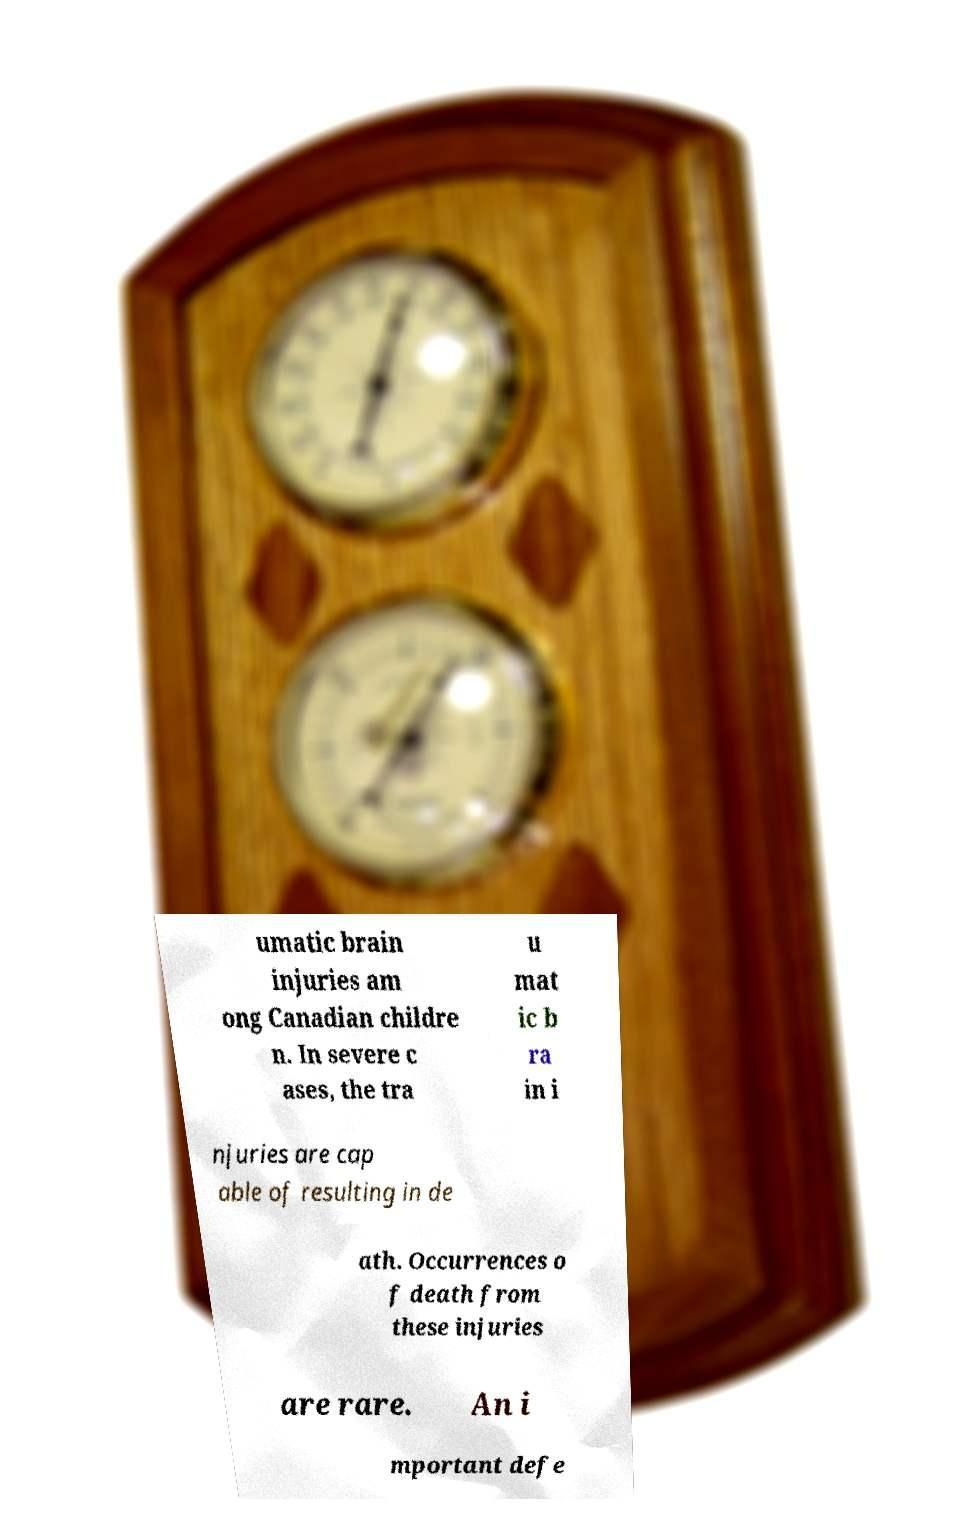Please identify and transcribe the text found in this image. umatic brain injuries am ong Canadian childre n. In severe c ases, the tra u mat ic b ra in i njuries are cap able of resulting in de ath. Occurrences o f death from these injuries are rare. An i mportant defe 